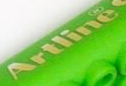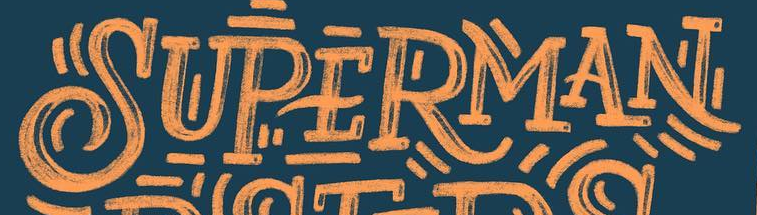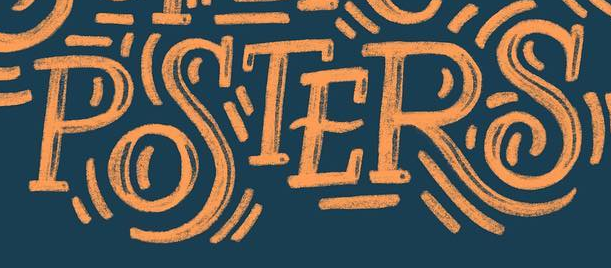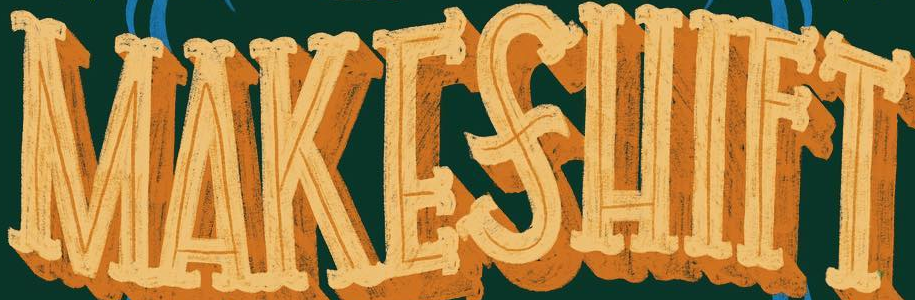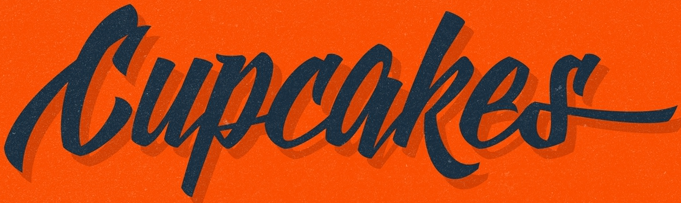What text appears in these images from left to right, separated by a semicolon? Artline; SUPERMAN; POSTERS; MAKESHIFT; Cupcakes 